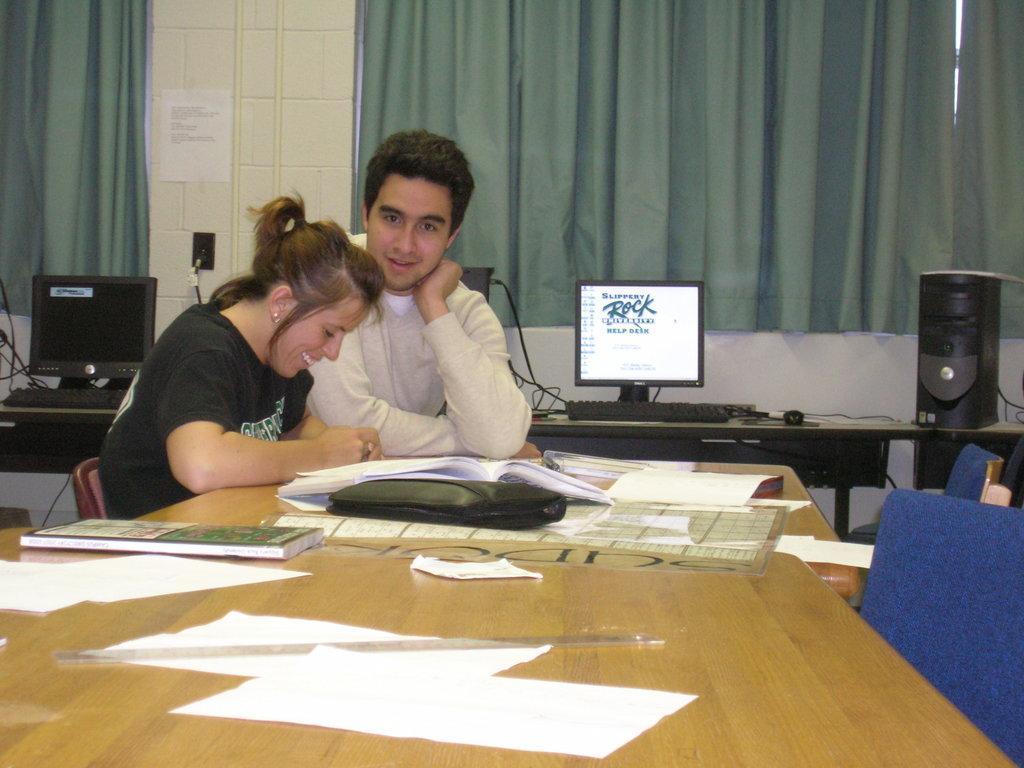Could you give a brief overview of what you see in this image? In this image there is one room the two people are sitting on the chair in front of the table the table contains books,papers,bag and behind the person there are so many laptops are there on the table and the two chairs and the background is white. 